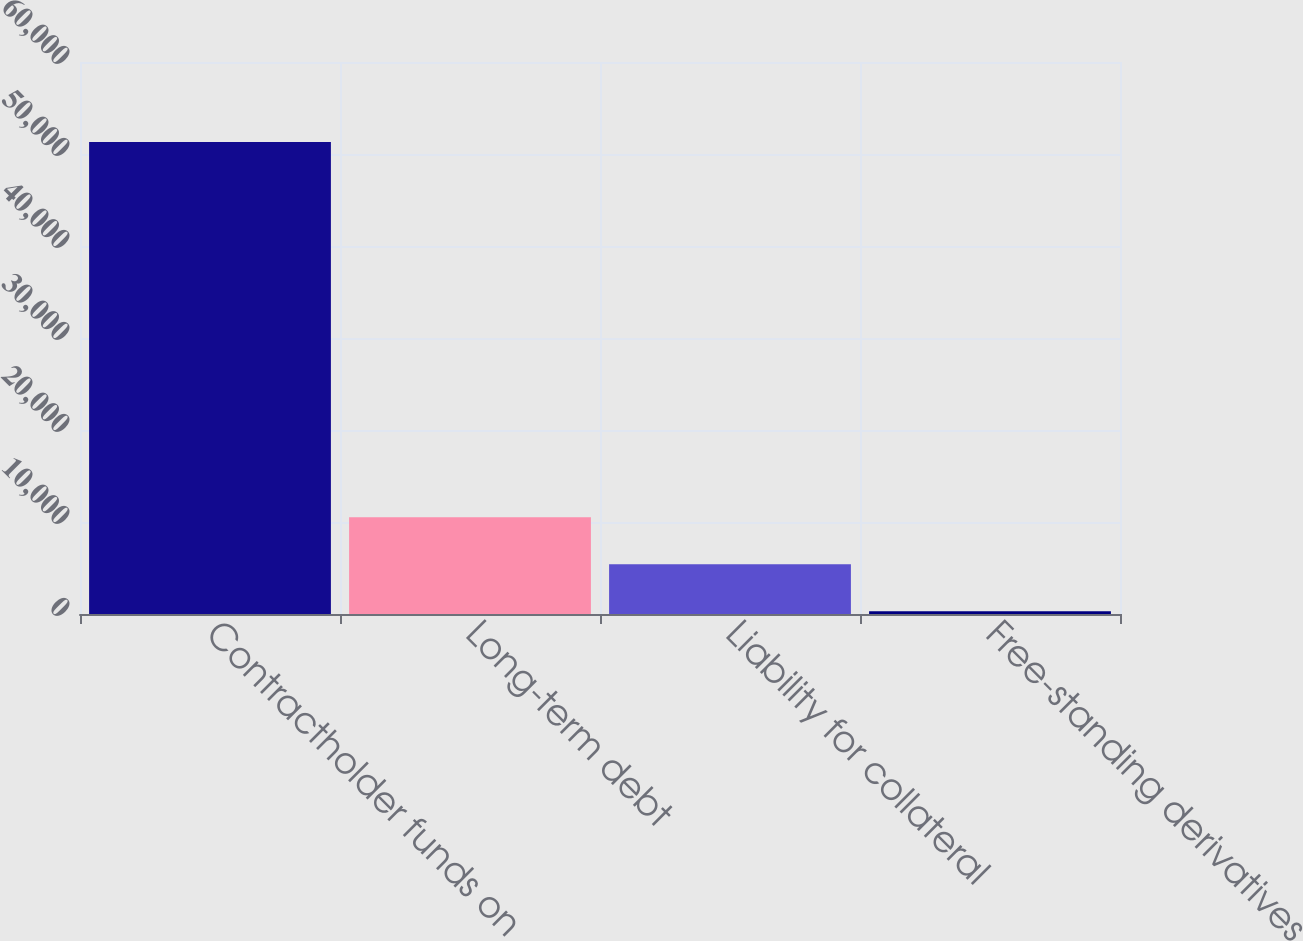Convert chart to OTSL. <chart><loc_0><loc_0><loc_500><loc_500><bar_chart><fcel>Contractholder funds on<fcel>Long-term debt<fcel>Liability for collateral<fcel>Free-standing derivatives<nl><fcel>51312<fcel>10511.2<fcel>5411.1<fcel>311<nl></chart> 